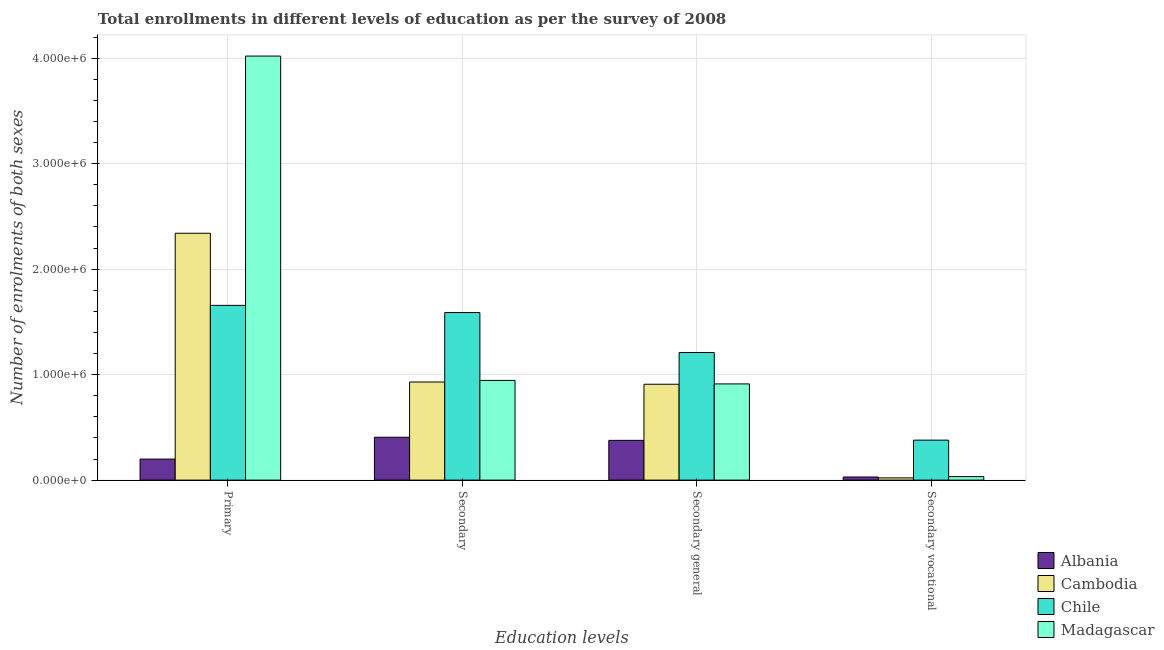How many groups of bars are there?
Keep it short and to the point. 4. Are the number of bars on each tick of the X-axis equal?
Offer a terse response. Yes. How many bars are there on the 3rd tick from the right?
Provide a short and direct response. 4. What is the label of the 4th group of bars from the left?
Give a very brief answer. Secondary vocational. What is the number of enrolments in primary education in Cambodia?
Your response must be concise. 2.34e+06. Across all countries, what is the maximum number of enrolments in secondary vocational education?
Offer a terse response. 3.79e+05. Across all countries, what is the minimum number of enrolments in secondary vocational education?
Offer a terse response. 2.12e+04. In which country was the number of enrolments in secondary general education maximum?
Provide a short and direct response. Chile. In which country was the number of enrolments in secondary vocational education minimum?
Provide a short and direct response. Cambodia. What is the total number of enrolments in secondary general education in the graph?
Keep it short and to the point. 3.41e+06. What is the difference between the number of enrolments in secondary vocational education in Madagascar and that in Chile?
Offer a very short reply. -3.46e+05. What is the difference between the number of enrolments in secondary education in Albania and the number of enrolments in primary education in Madagascar?
Provide a succinct answer. -3.61e+06. What is the average number of enrolments in secondary education per country?
Your answer should be compact. 9.68e+05. What is the difference between the number of enrolments in secondary general education and number of enrolments in secondary education in Madagascar?
Your answer should be compact. -3.31e+04. What is the ratio of the number of enrolments in secondary general education in Madagascar to that in Chile?
Provide a succinct answer. 0.75. What is the difference between the highest and the second highest number of enrolments in primary education?
Ensure brevity in your answer.  1.68e+06. What is the difference between the highest and the lowest number of enrolments in secondary education?
Make the answer very short. 1.18e+06. Is the sum of the number of enrolments in secondary general education in Cambodia and Madagascar greater than the maximum number of enrolments in secondary education across all countries?
Your answer should be very brief. Yes. Is it the case that in every country, the sum of the number of enrolments in secondary vocational education and number of enrolments in primary education is greater than the sum of number of enrolments in secondary general education and number of enrolments in secondary education?
Provide a short and direct response. No. What does the 3rd bar from the left in Primary represents?
Provide a succinct answer. Chile. What does the 2nd bar from the right in Secondary general represents?
Your response must be concise. Chile. How many bars are there?
Give a very brief answer. 16. Are all the bars in the graph horizontal?
Provide a succinct answer. No. How many countries are there in the graph?
Offer a terse response. 4. Are the values on the major ticks of Y-axis written in scientific E-notation?
Provide a succinct answer. Yes. Does the graph contain any zero values?
Offer a very short reply. No. Does the graph contain grids?
Make the answer very short. Yes. Where does the legend appear in the graph?
Give a very brief answer. Bottom right. How many legend labels are there?
Make the answer very short. 4. How are the legend labels stacked?
Give a very brief answer. Vertical. What is the title of the graph?
Make the answer very short. Total enrollments in different levels of education as per the survey of 2008. Does "Ireland" appear as one of the legend labels in the graph?
Your answer should be very brief. No. What is the label or title of the X-axis?
Keep it short and to the point. Education levels. What is the label or title of the Y-axis?
Your answer should be very brief. Number of enrolments of both sexes. What is the Number of enrolments of both sexes in Albania in Primary?
Ensure brevity in your answer.  1.99e+05. What is the Number of enrolments of both sexes in Cambodia in Primary?
Your response must be concise. 2.34e+06. What is the Number of enrolments of both sexes in Chile in Primary?
Provide a short and direct response. 1.66e+06. What is the Number of enrolments of both sexes of Madagascar in Primary?
Your answer should be compact. 4.02e+06. What is the Number of enrolments of both sexes in Albania in Secondary?
Provide a succinct answer. 4.07e+05. What is the Number of enrolments of both sexes of Cambodia in Secondary?
Ensure brevity in your answer.  9.30e+05. What is the Number of enrolments of both sexes of Chile in Secondary?
Offer a terse response. 1.59e+06. What is the Number of enrolments of both sexes of Madagascar in Secondary?
Offer a very short reply. 9.45e+05. What is the Number of enrolments of both sexes in Albania in Secondary general?
Your answer should be very brief. 3.77e+05. What is the Number of enrolments of both sexes in Cambodia in Secondary general?
Offer a terse response. 9.09e+05. What is the Number of enrolments of both sexes in Chile in Secondary general?
Your response must be concise. 1.21e+06. What is the Number of enrolments of both sexes of Madagascar in Secondary general?
Make the answer very short. 9.12e+05. What is the Number of enrolments of both sexes in Albania in Secondary vocational?
Make the answer very short. 2.97e+04. What is the Number of enrolments of both sexes in Cambodia in Secondary vocational?
Your answer should be very brief. 2.12e+04. What is the Number of enrolments of both sexes in Chile in Secondary vocational?
Give a very brief answer. 3.79e+05. What is the Number of enrolments of both sexes of Madagascar in Secondary vocational?
Your response must be concise. 3.31e+04. Across all Education levels, what is the maximum Number of enrolments of both sexes of Albania?
Make the answer very short. 4.07e+05. Across all Education levels, what is the maximum Number of enrolments of both sexes in Cambodia?
Make the answer very short. 2.34e+06. Across all Education levels, what is the maximum Number of enrolments of both sexes of Chile?
Provide a short and direct response. 1.66e+06. Across all Education levels, what is the maximum Number of enrolments of both sexes of Madagascar?
Offer a terse response. 4.02e+06. Across all Education levels, what is the minimum Number of enrolments of both sexes of Albania?
Provide a short and direct response. 2.97e+04. Across all Education levels, what is the minimum Number of enrolments of both sexes in Cambodia?
Your response must be concise. 2.12e+04. Across all Education levels, what is the minimum Number of enrolments of both sexes of Chile?
Offer a terse response. 3.79e+05. Across all Education levels, what is the minimum Number of enrolments of both sexes in Madagascar?
Your answer should be very brief. 3.31e+04. What is the total Number of enrolments of both sexes of Albania in the graph?
Offer a terse response. 1.01e+06. What is the total Number of enrolments of both sexes in Cambodia in the graph?
Provide a short and direct response. 4.20e+06. What is the total Number of enrolments of both sexes of Chile in the graph?
Give a very brief answer. 4.83e+06. What is the total Number of enrolments of both sexes in Madagascar in the graph?
Ensure brevity in your answer.  5.91e+06. What is the difference between the Number of enrolments of both sexes in Albania in Primary and that in Secondary?
Offer a terse response. -2.07e+05. What is the difference between the Number of enrolments of both sexes in Cambodia in Primary and that in Secondary?
Offer a terse response. 1.41e+06. What is the difference between the Number of enrolments of both sexes of Chile in Primary and that in Secondary?
Offer a terse response. 6.80e+04. What is the difference between the Number of enrolments of both sexes in Madagascar in Primary and that in Secondary?
Your response must be concise. 3.08e+06. What is the difference between the Number of enrolments of both sexes of Albania in Primary and that in Secondary general?
Offer a terse response. -1.77e+05. What is the difference between the Number of enrolments of both sexes of Cambodia in Primary and that in Secondary general?
Offer a terse response. 1.43e+06. What is the difference between the Number of enrolments of both sexes of Chile in Primary and that in Secondary general?
Ensure brevity in your answer.  4.47e+05. What is the difference between the Number of enrolments of both sexes of Madagascar in Primary and that in Secondary general?
Your answer should be very brief. 3.11e+06. What is the difference between the Number of enrolments of both sexes of Albania in Primary and that in Secondary vocational?
Your answer should be very brief. 1.70e+05. What is the difference between the Number of enrolments of both sexes in Cambodia in Primary and that in Secondary vocational?
Offer a terse response. 2.32e+06. What is the difference between the Number of enrolments of both sexes of Chile in Primary and that in Secondary vocational?
Provide a succinct answer. 1.28e+06. What is the difference between the Number of enrolments of both sexes in Madagascar in Primary and that in Secondary vocational?
Ensure brevity in your answer.  3.99e+06. What is the difference between the Number of enrolments of both sexes of Albania in Secondary and that in Secondary general?
Make the answer very short. 2.97e+04. What is the difference between the Number of enrolments of both sexes in Cambodia in Secondary and that in Secondary general?
Your response must be concise. 2.12e+04. What is the difference between the Number of enrolments of both sexes in Chile in Secondary and that in Secondary general?
Your answer should be very brief. 3.79e+05. What is the difference between the Number of enrolments of both sexes in Madagascar in Secondary and that in Secondary general?
Your answer should be very brief. 3.31e+04. What is the difference between the Number of enrolments of both sexes in Albania in Secondary and that in Secondary vocational?
Your answer should be very brief. 3.77e+05. What is the difference between the Number of enrolments of both sexes in Cambodia in Secondary and that in Secondary vocational?
Provide a succinct answer. 9.09e+05. What is the difference between the Number of enrolments of both sexes in Chile in Secondary and that in Secondary vocational?
Provide a short and direct response. 1.21e+06. What is the difference between the Number of enrolments of both sexes in Madagascar in Secondary and that in Secondary vocational?
Offer a terse response. 9.12e+05. What is the difference between the Number of enrolments of both sexes in Albania in Secondary general and that in Secondary vocational?
Provide a succinct answer. 3.47e+05. What is the difference between the Number of enrolments of both sexes of Cambodia in Secondary general and that in Secondary vocational?
Your answer should be very brief. 8.88e+05. What is the difference between the Number of enrolments of both sexes of Chile in Secondary general and that in Secondary vocational?
Provide a short and direct response. 8.31e+05. What is the difference between the Number of enrolments of both sexes of Madagascar in Secondary general and that in Secondary vocational?
Offer a very short reply. 8.79e+05. What is the difference between the Number of enrolments of both sexes of Albania in Primary and the Number of enrolments of both sexes of Cambodia in Secondary?
Offer a terse response. -7.31e+05. What is the difference between the Number of enrolments of both sexes in Albania in Primary and the Number of enrolments of both sexes in Chile in Secondary?
Offer a terse response. -1.39e+06. What is the difference between the Number of enrolments of both sexes of Albania in Primary and the Number of enrolments of both sexes of Madagascar in Secondary?
Ensure brevity in your answer.  -7.46e+05. What is the difference between the Number of enrolments of both sexes of Cambodia in Primary and the Number of enrolments of both sexes of Chile in Secondary?
Offer a very short reply. 7.52e+05. What is the difference between the Number of enrolments of both sexes in Cambodia in Primary and the Number of enrolments of both sexes in Madagascar in Secondary?
Ensure brevity in your answer.  1.40e+06. What is the difference between the Number of enrolments of both sexes in Chile in Primary and the Number of enrolments of both sexes in Madagascar in Secondary?
Keep it short and to the point. 7.12e+05. What is the difference between the Number of enrolments of both sexes in Albania in Primary and the Number of enrolments of both sexes in Cambodia in Secondary general?
Provide a short and direct response. -7.10e+05. What is the difference between the Number of enrolments of both sexes of Albania in Primary and the Number of enrolments of both sexes of Chile in Secondary general?
Offer a very short reply. -1.01e+06. What is the difference between the Number of enrolments of both sexes in Albania in Primary and the Number of enrolments of both sexes in Madagascar in Secondary general?
Give a very brief answer. -7.13e+05. What is the difference between the Number of enrolments of both sexes in Cambodia in Primary and the Number of enrolments of both sexes in Chile in Secondary general?
Your response must be concise. 1.13e+06. What is the difference between the Number of enrolments of both sexes of Cambodia in Primary and the Number of enrolments of both sexes of Madagascar in Secondary general?
Ensure brevity in your answer.  1.43e+06. What is the difference between the Number of enrolments of both sexes in Chile in Primary and the Number of enrolments of both sexes in Madagascar in Secondary general?
Give a very brief answer. 7.45e+05. What is the difference between the Number of enrolments of both sexes of Albania in Primary and the Number of enrolments of both sexes of Cambodia in Secondary vocational?
Provide a succinct answer. 1.78e+05. What is the difference between the Number of enrolments of both sexes of Albania in Primary and the Number of enrolments of both sexes of Chile in Secondary vocational?
Your response must be concise. -1.80e+05. What is the difference between the Number of enrolments of both sexes in Albania in Primary and the Number of enrolments of both sexes in Madagascar in Secondary vocational?
Your answer should be very brief. 1.66e+05. What is the difference between the Number of enrolments of both sexes of Cambodia in Primary and the Number of enrolments of both sexes of Chile in Secondary vocational?
Your response must be concise. 1.96e+06. What is the difference between the Number of enrolments of both sexes in Cambodia in Primary and the Number of enrolments of both sexes in Madagascar in Secondary vocational?
Keep it short and to the point. 2.31e+06. What is the difference between the Number of enrolments of both sexes in Chile in Primary and the Number of enrolments of both sexes in Madagascar in Secondary vocational?
Your answer should be compact. 1.62e+06. What is the difference between the Number of enrolments of both sexes of Albania in Secondary and the Number of enrolments of both sexes of Cambodia in Secondary general?
Ensure brevity in your answer.  -5.02e+05. What is the difference between the Number of enrolments of both sexes in Albania in Secondary and the Number of enrolments of both sexes in Chile in Secondary general?
Keep it short and to the point. -8.03e+05. What is the difference between the Number of enrolments of both sexes of Albania in Secondary and the Number of enrolments of both sexes of Madagascar in Secondary general?
Your response must be concise. -5.06e+05. What is the difference between the Number of enrolments of both sexes of Cambodia in Secondary and the Number of enrolments of both sexes of Chile in Secondary general?
Ensure brevity in your answer.  -2.80e+05. What is the difference between the Number of enrolments of both sexes in Cambodia in Secondary and the Number of enrolments of both sexes in Madagascar in Secondary general?
Provide a short and direct response. 1.80e+04. What is the difference between the Number of enrolments of both sexes in Chile in Secondary and the Number of enrolments of both sexes in Madagascar in Secondary general?
Ensure brevity in your answer.  6.77e+05. What is the difference between the Number of enrolments of both sexes in Albania in Secondary and the Number of enrolments of both sexes in Cambodia in Secondary vocational?
Your answer should be very brief. 3.85e+05. What is the difference between the Number of enrolments of both sexes in Albania in Secondary and the Number of enrolments of both sexes in Chile in Secondary vocational?
Make the answer very short. 2.74e+04. What is the difference between the Number of enrolments of both sexes in Albania in Secondary and the Number of enrolments of both sexes in Madagascar in Secondary vocational?
Your response must be concise. 3.73e+05. What is the difference between the Number of enrolments of both sexes in Cambodia in Secondary and the Number of enrolments of both sexes in Chile in Secondary vocational?
Offer a very short reply. 5.51e+05. What is the difference between the Number of enrolments of both sexes of Cambodia in Secondary and the Number of enrolments of both sexes of Madagascar in Secondary vocational?
Ensure brevity in your answer.  8.97e+05. What is the difference between the Number of enrolments of both sexes of Chile in Secondary and the Number of enrolments of both sexes of Madagascar in Secondary vocational?
Provide a short and direct response. 1.56e+06. What is the difference between the Number of enrolments of both sexes of Albania in Secondary general and the Number of enrolments of both sexes of Cambodia in Secondary vocational?
Make the answer very short. 3.56e+05. What is the difference between the Number of enrolments of both sexes of Albania in Secondary general and the Number of enrolments of both sexes of Chile in Secondary vocational?
Offer a terse response. -2214. What is the difference between the Number of enrolments of both sexes in Albania in Secondary general and the Number of enrolments of both sexes in Madagascar in Secondary vocational?
Your response must be concise. 3.44e+05. What is the difference between the Number of enrolments of both sexes of Cambodia in Secondary general and the Number of enrolments of both sexes of Chile in Secondary vocational?
Give a very brief answer. 5.30e+05. What is the difference between the Number of enrolments of both sexes in Cambodia in Secondary general and the Number of enrolments of both sexes in Madagascar in Secondary vocational?
Give a very brief answer. 8.76e+05. What is the difference between the Number of enrolments of both sexes of Chile in Secondary general and the Number of enrolments of both sexes of Madagascar in Secondary vocational?
Make the answer very short. 1.18e+06. What is the average Number of enrolments of both sexes in Albania per Education levels?
Your response must be concise. 2.53e+05. What is the average Number of enrolments of both sexes in Cambodia per Education levels?
Your response must be concise. 1.05e+06. What is the average Number of enrolments of both sexes of Chile per Education levels?
Make the answer very short. 1.21e+06. What is the average Number of enrolments of both sexes of Madagascar per Education levels?
Offer a very short reply. 1.48e+06. What is the difference between the Number of enrolments of both sexes of Albania and Number of enrolments of both sexes of Cambodia in Primary?
Offer a very short reply. -2.14e+06. What is the difference between the Number of enrolments of both sexes of Albania and Number of enrolments of both sexes of Chile in Primary?
Give a very brief answer. -1.46e+06. What is the difference between the Number of enrolments of both sexes in Albania and Number of enrolments of both sexes in Madagascar in Primary?
Make the answer very short. -3.82e+06. What is the difference between the Number of enrolments of both sexes of Cambodia and Number of enrolments of both sexes of Chile in Primary?
Your answer should be compact. 6.84e+05. What is the difference between the Number of enrolments of both sexes of Cambodia and Number of enrolments of both sexes of Madagascar in Primary?
Make the answer very short. -1.68e+06. What is the difference between the Number of enrolments of both sexes in Chile and Number of enrolments of both sexes in Madagascar in Primary?
Ensure brevity in your answer.  -2.36e+06. What is the difference between the Number of enrolments of both sexes in Albania and Number of enrolments of both sexes in Cambodia in Secondary?
Ensure brevity in your answer.  -5.24e+05. What is the difference between the Number of enrolments of both sexes of Albania and Number of enrolments of both sexes of Chile in Secondary?
Keep it short and to the point. -1.18e+06. What is the difference between the Number of enrolments of both sexes in Albania and Number of enrolments of both sexes in Madagascar in Secondary?
Give a very brief answer. -5.39e+05. What is the difference between the Number of enrolments of both sexes in Cambodia and Number of enrolments of both sexes in Chile in Secondary?
Offer a terse response. -6.59e+05. What is the difference between the Number of enrolments of both sexes of Cambodia and Number of enrolments of both sexes of Madagascar in Secondary?
Your answer should be compact. -1.50e+04. What is the difference between the Number of enrolments of both sexes of Chile and Number of enrolments of both sexes of Madagascar in Secondary?
Provide a short and direct response. 6.44e+05. What is the difference between the Number of enrolments of both sexes of Albania and Number of enrolments of both sexes of Cambodia in Secondary general?
Offer a very short reply. -5.32e+05. What is the difference between the Number of enrolments of both sexes of Albania and Number of enrolments of both sexes of Chile in Secondary general?
Provide a short and direct response. -8.33e+05. What is the difference between the Number of enrolments of both sexes in Albania and Number of enrolments of both sexes in Madagascar in Secondary general?
Your answer should be compact. -5.35e+05. What is the difference between the Number of enrolments of both sexes of Cambodia and Number of enrolments of both sexes of Chile in Secondary general?
Give a very brief answer. -3.01e+05. What is the difference between the Number of enrolments of both sexes of Cambodia and Number of enrolments of both sexes of Madagascar in Secondary general?
Offer a very short reply. -3120. What is the difference between the Number of enrolments of both sexes in Chile and Number of enrolments of both sexes in Madagascar in Secondary general?
Keep it short and to the point. 2.98e+05. What is the difference between the Number of enrolments of both sexes of Albania and Number of enrolments of both sexes of Cambodia in Secondary vocational?
Your answer should be very brief. 8485. What is the difference between the Number of enrolments of both sexes of Albania and Number of enrolments of both sexes of Chile in Secondary vocational?
Offer a terse response. -3.49e+05. What is the difference between the Number of enrolments of both sexes of Albania and Number of enrolments of both sexes of Madagascar in Secondary vocational?
Your response must be concise. -3440. What is the difference between the Number of enrolments of both sexes in Cambodia and Number of enrolments of both sexes in Chile in Secondary vocational?
Your answer should be very brief. -3.58e+05. What is the difference between the Number of enrolments of both sexes of Cambodia and Number of enrolments of both sexes of Madagascar in Secondary vocational?
Offer a terse response. -1.19e+04. What is the difference between the Number of enrolments of both sexes of Chile and Number of enrolments of both sexes of Madagascar in Secondary vocational?
Your response must be concise. 3.46e+05. What is the ratio of the Number of enrolments of both sexes of Albania in Primary to that in Secondary?
Make the answer very short. 0.49. What is the ratio of the Number of enrolments of both sexes of Cambodia in Primary to that in Secondary?
Ensure brevity in your answer.  2.52. What is the ratio of the Number of enrolments of both sexes in Chile in Primary to that in Secondary?
Offer a terse response. 1.04. What is the ratio of the Number of enrolments of both sexes in Madagascar in Primary to that in Secondary?
Offer a terse response. 4.25. What is the ratio of the Number of enrolments of both sexes in Albania in Primary to that in Secondary general?
Provide a short and direct response. 0.53. What is the ratio of the Number of enrolments of both sexes in Cambodia in Primary to that in Secondary general?
Offer a terse response. 2.57. What is the ratio of the Number of enrolments of both sexes in Chile in Primary to that in Secondary general?
Give a very brief answer. 1.37. What is the ratio of the Number of enrolments of both sexes in Madagascar in Primary to that in Secondary general?
Offer a very short reply. 4.41. What is the ratio of the Number of enrolments of both sexes of Albania in Primary to that in Secondary vocational?
Keep it short and to the point. 6.73. What is the ratio of the Number of enrolments of both sexes in Cambodia in Primary to that in Secondary vocational?
Provide a short and direct response. 110.58. What is the ratio of the Number of enrolments of both sexes of Chile in Primary to that in Secondary vocational?
Provide a short and direct response. 4.37. What is the ratio of the Number of enrolments of both sexes of Madagascar in Primary to that in Secondary vocational?
Your answer should be very brief. 121.49. What is the ratio of the Number of enrolments of both sexes in Albania in Secondary to that in Secondary general?
Offer a terse response. 1.08. What is the ratio of the Number of enrolments of both sexes of Cambodia in Secondary to that in Secondary general?
Offer a terse response. 1.02. What is the ratio of the Number of enrolments of both sexes of Chile in Secondary to that in Secondary general?
Your answer should be compact. 1.31. What is the ratio of the Number of enrolments of both sexes in Madagascar in Secondary to that in Secondary general?
Make the answer very short. 1.04. What is the ratio of the Number of enrolments of both sexes of Albania in Secondary to that in Secondary vocational?
Give a very brief answer. 13.71. What is the ratio of the Number of enrolments of both sexes in Cambodia in Secondary to that in Secondary vocational?
Your response must be concise. 43.95. What is the ratio of the Number of enrolments of both sexes of Chile in Secondary to that in Secondary vocational?
Make the answer very short. 4.19. What is the ratio of the Number of enrolments of both sexes of Madagascar in Secondary to that in Secondary vocational?
Your answer should be very brief. 28.56. What is the ratio of the Number of enrolments of both sexes of Albania in Secondary general to that in Secondary vocational?
Offer a very short reply. 12.71. What is the ratio of the Number of enrolments of both sexes of Cambodia in Secondary general to that in Secondary vocational?
Make the answer very short. 42.95. What is the ratio of the Number of enrolments of both sexes in Chile in Secondary general to that in Secondary vocational?
Your answer should be compact. 3.19. What is the ratio of the Number of enrolments of both sexes in Madagascar in Secondary general to that in Secondary vocational?
Ensure brevity in your answer.  27.56. What is the difference between the highest and the second highest Number of enrolments of both sexes of Albania?
Your response must be concise. 2.97e+04. What is the difference between the highest and the second highest Number of enrolments of both sexes of Cambodia?
Your answer should be compact. 1.41e+06. What is the difference between the highest and the second highest Number of enrolments of both sexes of Chile?
Give a very brief answer. 6.80e+04. What is the difference between the highest and the second highest Number of enrolments of both sexes in Madagascar?
Keep it short and to the point. 3.08e+06. What is the difference between the highest and the lowest Number of enrolments of both sexes in Albania?
Offer a terse response. 3.77e+05. What is the difference between the highest and the lowest Number of enrolments of both sexes in Cambodia?
Ensure brevity in your answer.  2.32e+06. What is the difference between the highest and the lowest Number of enrolments of both sexes in Chile?
Provide a succinct answer. 1.28e+06. What is the difference between the highest and the lowest Number of enrolments of both sexes of Madagascar?
Make the answer very short. 3.99e+06. 